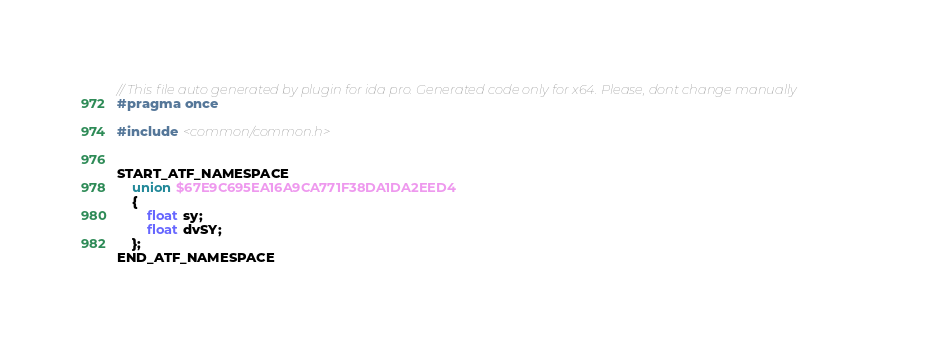Convert code to text. <code><loc_0><loc_0><loc_500><loc_500><_C++_>// This file auto generated by plugin for ida pro. Generated code only for x64. Please, dont change manually
#pragma once

#include <common/common.h>


START_ATF_NAMESPACE
    union $67E9C695EA16A9CA771F38DA1DA2EED4
    {
        float sy;
        float dvSY;
    };
END_ATF_NAMESPACE
</code> 